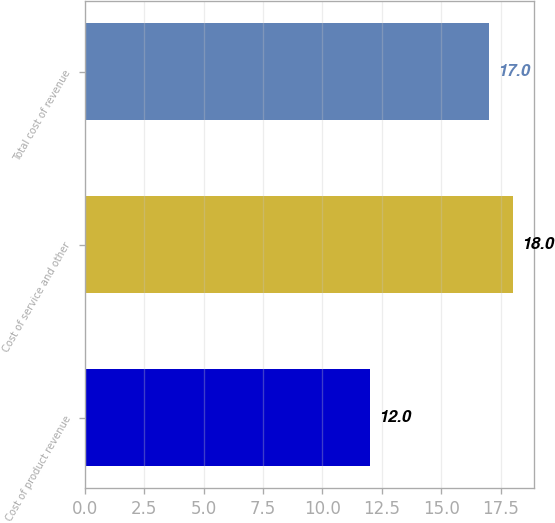Convert chart. <chart><loc_0><loc_0><loc_500><loc_500><bar_chart><fcel>Cost of product revenue<fcel>Cost of service and other<fcel>Total cost of revenue<nl><fcel>12<fcel>18<fcel>17<nl></chart> 